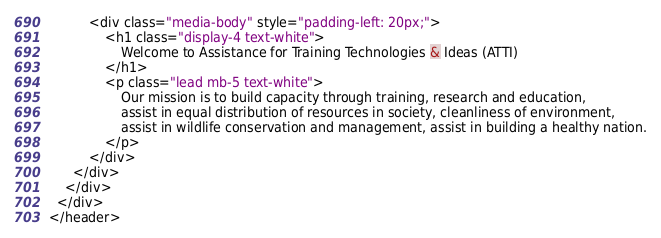<code> <loc_0><loc_0><loc_500><loc_500><_HTML_>          <div class="media-body" style="padding-left: 20px;">
              <h1 class="display-4 text-white">
                  Welcome to Assistance for Training Technologies & Ideas (ATTI)
              </h1>
              <p class="lead mb-5 text-white">
                  Our mission is to build capacity through training, research and education,
                  assist in equal distribution of resources in society, cleanliness of environment,
                  assist in wildlife conservation and management, assist in building a healthy nation.
              </p>
          </div>
      </div>
    </div>
  </div>
</header>
</code> 